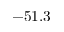Convert formula to latex. <formula><loc_0><loc_0><loc_500><loc_500>- 5 1 . 3</formula> 